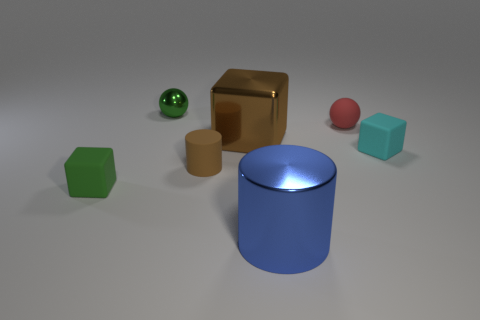Subtract all cyan blocks. How many blocks are left? 2 Add 1 tiny green matte things. How many objects exist? 8 Subtract 2 balls. How many balls are left? 0 Subtract all blocks. How many objects are left? 4 Subtract all blue cylinders. How many cylinders are left? 1 Subtract 0 blue cubes. How many objects are left? 7 Subtract all blue spheres. Subtract all purple blocks. How many spheres are left? 2 Subtract all small matte things. Subtract all brown things. How many objects are left? 1 Add 6 small brown matte things. How many small brown matte things are left? 7 Add 3 red matte things. How many red matte things exist? 4 